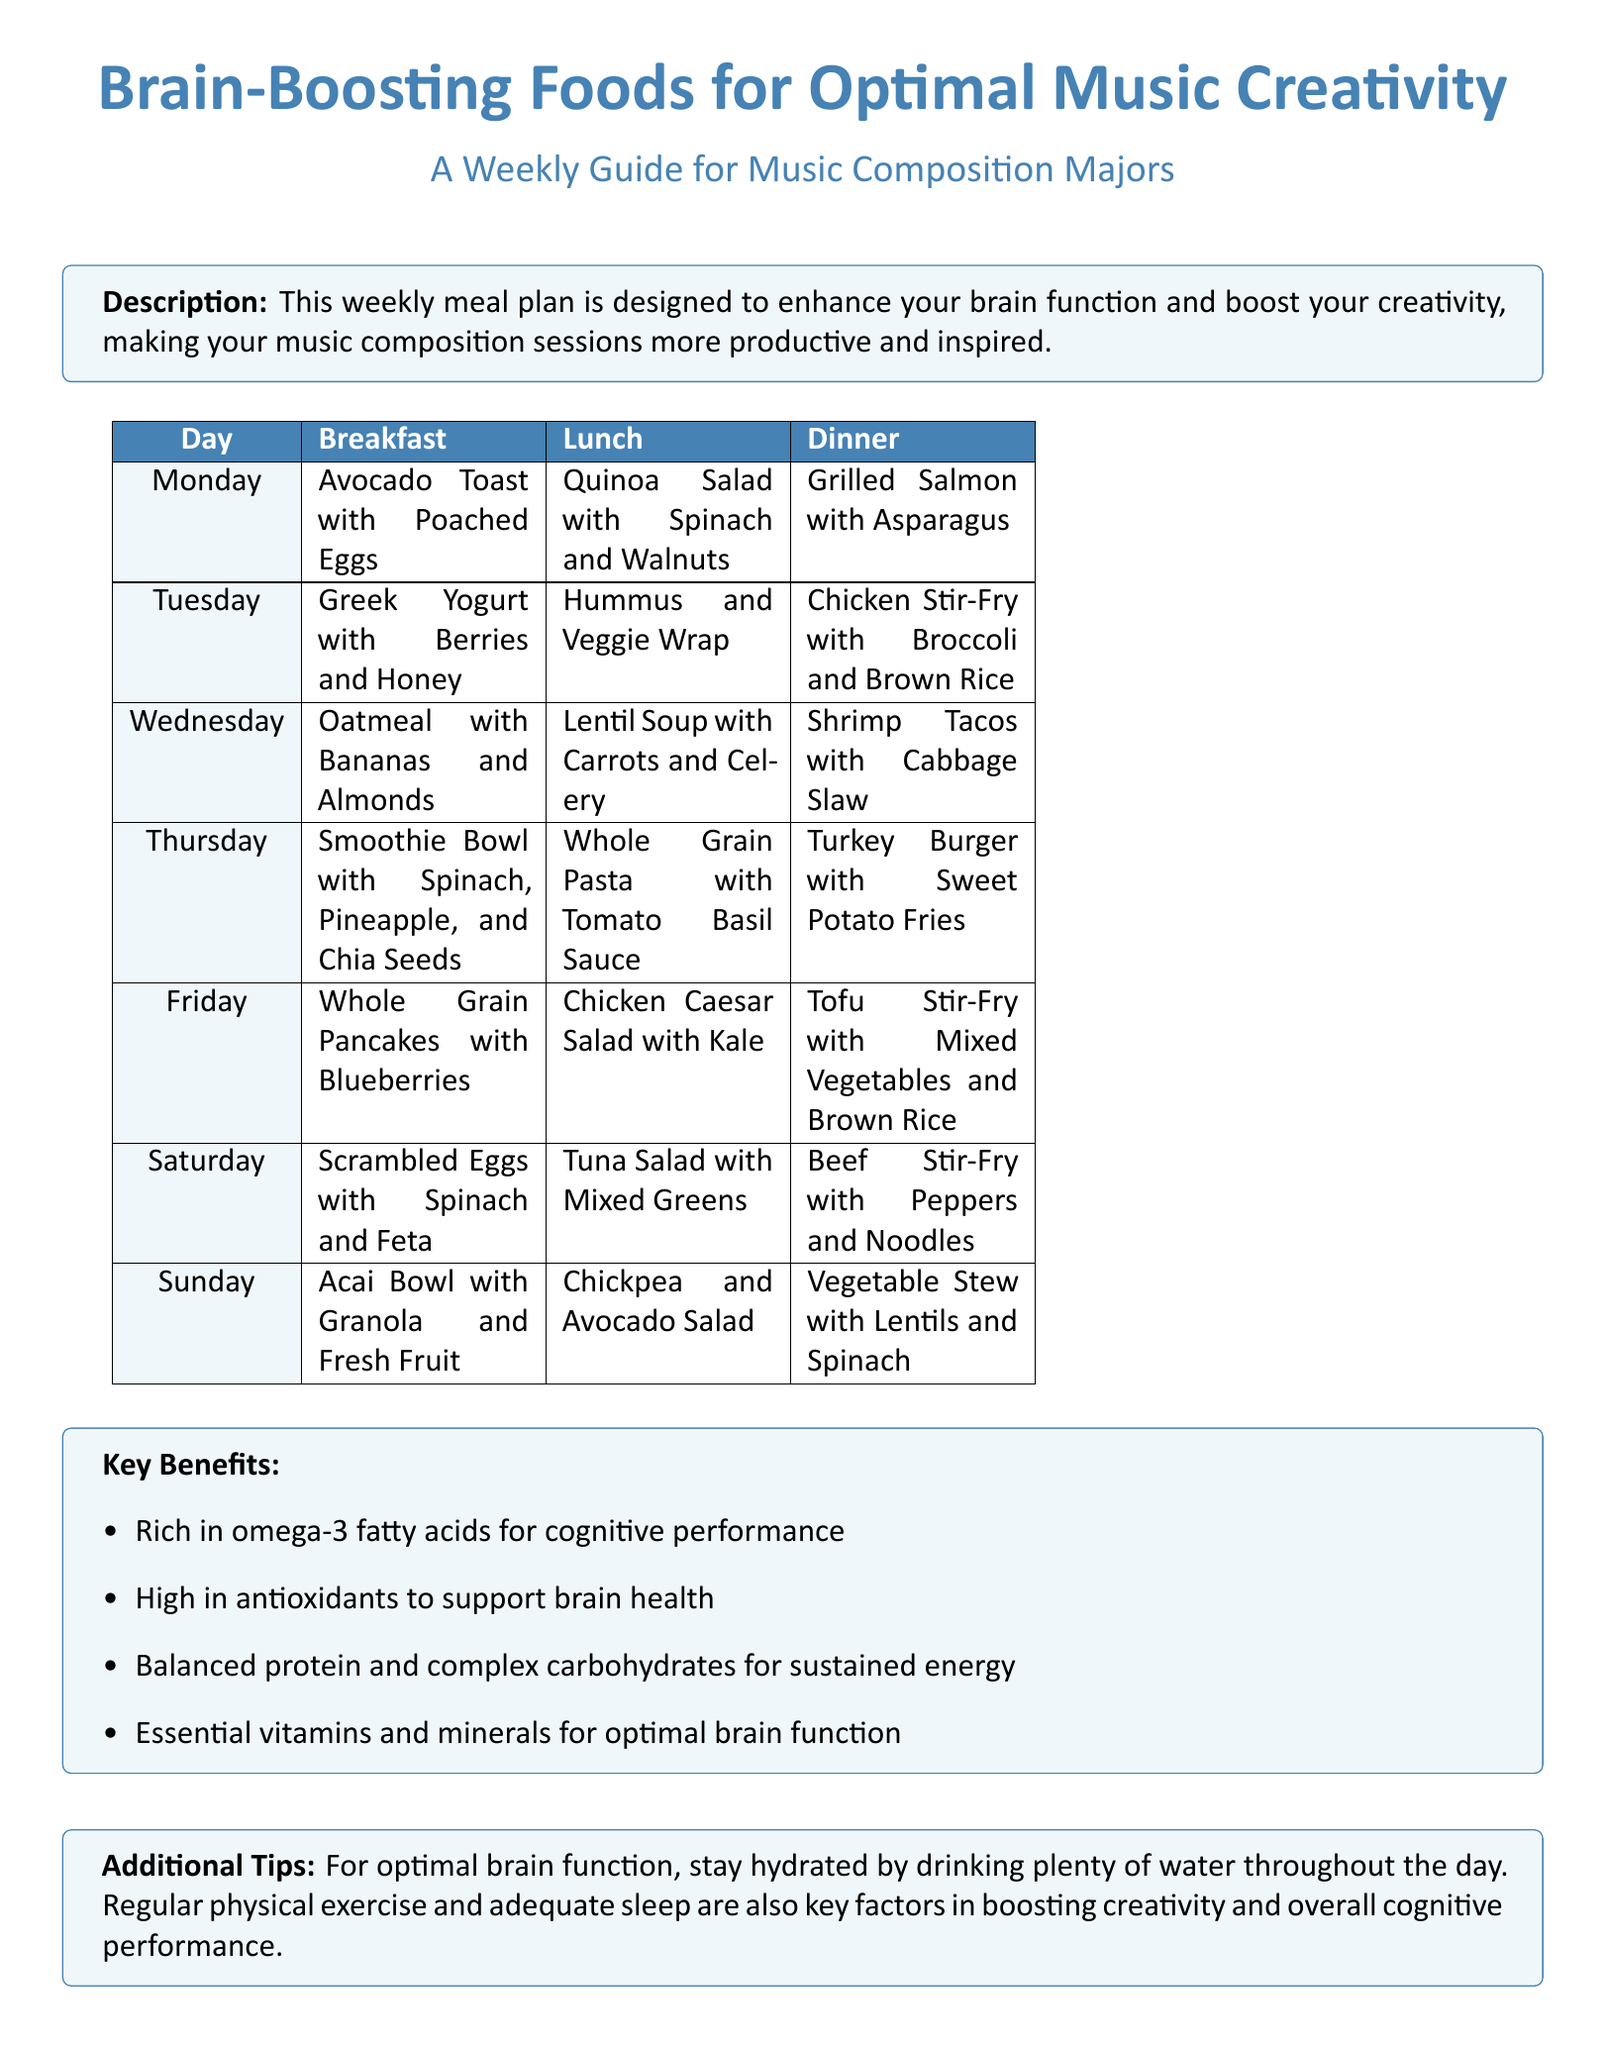What is the main focus of the meal plan? The main focus is to enhance brain function and boost creativity for music composition sessions.
Answer: Enhance brain function and boost creativity What day features Tofu Stir-Fry for dinner? By looking at the dinner options, Tofu Stir-Fry is mentioned for Friday.
Answer: Friday Which food is used in the breakfast on Saturday? The Saturday breakfast includes Scrambled Eggs with Spinach and Feta.
Answer: Scrambled Eggs with Spinach and Feta What is included in the key benefits of the meal plan? The key benefits list includes high antioxidants to support brain health.
Answer: High in antioxidants How many meals are planned for Sunday? There are three meals planned for Sunday according to the table.
Answer: Three What type of salad is served for lunch on Tuesday? The lunch on Tuesday consists of a Hummus and Veggie Wrap.
Answer: Hummus and Veggie Wrap What should you do for optimal brain function besides eating well? The document suggests staying hydrated by drinking plenty of water throughout the day.
Answer: Stay hydrated What is a major ingredient in Wednesday's lunch? Lentil Soup with Carrots and Celery is the lunch on Wednesday.
Answer: Lentils What are the meals with a source of protein for dinner on Monday? Grilled Salmon with Asparagus is the dinner with a protein source on Monday.
Answer: Grilled Salmon with Asparagus 